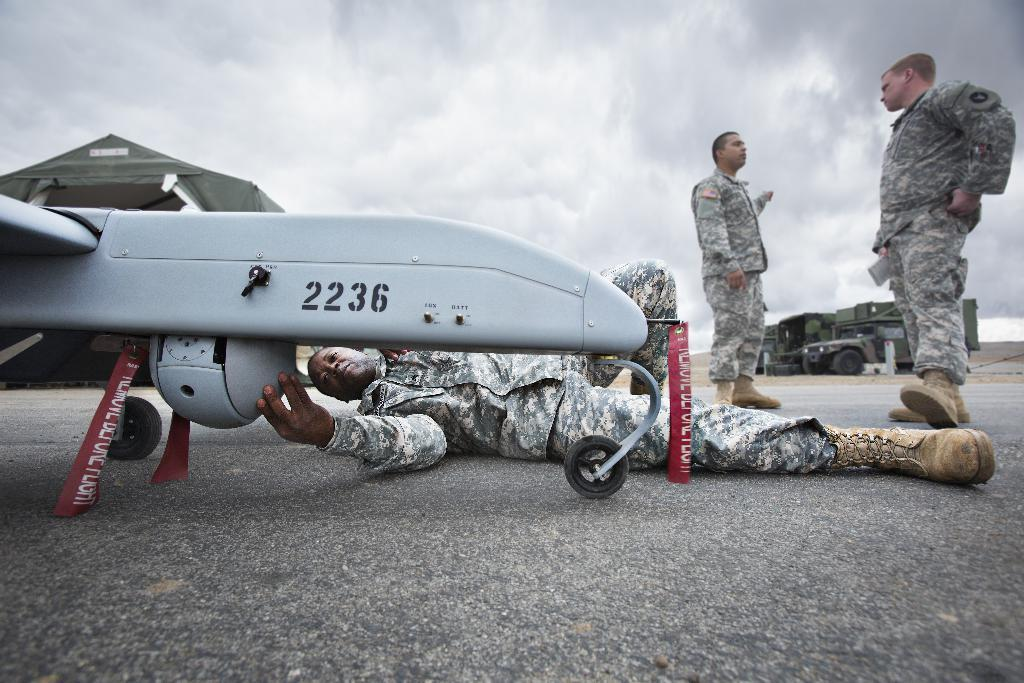<image>
Share a concise interpretation of the image provided. A man in an army uniform lies on the ground and works on 2236. 